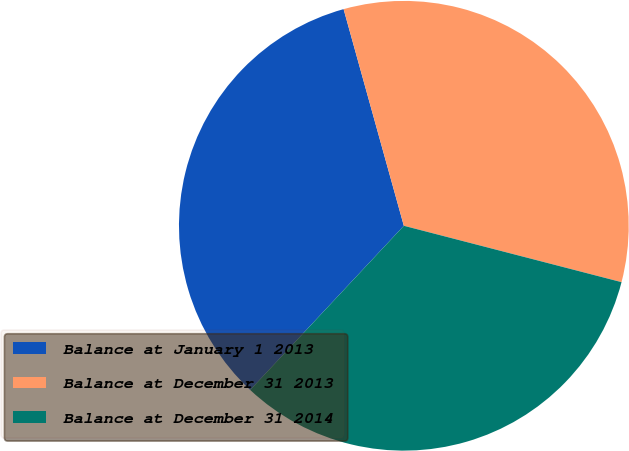Convert chart. <chart><loc_0><loc_0><loc_500><loc_500><pie_chart><fcel>Balance at January 1 2013<fcel>Balance at December 31 2013<fcel>Balance at December 31 2014<nl><fcel>33.71%<fcel>33.35%<fcel>32.94%<nl></chart> 